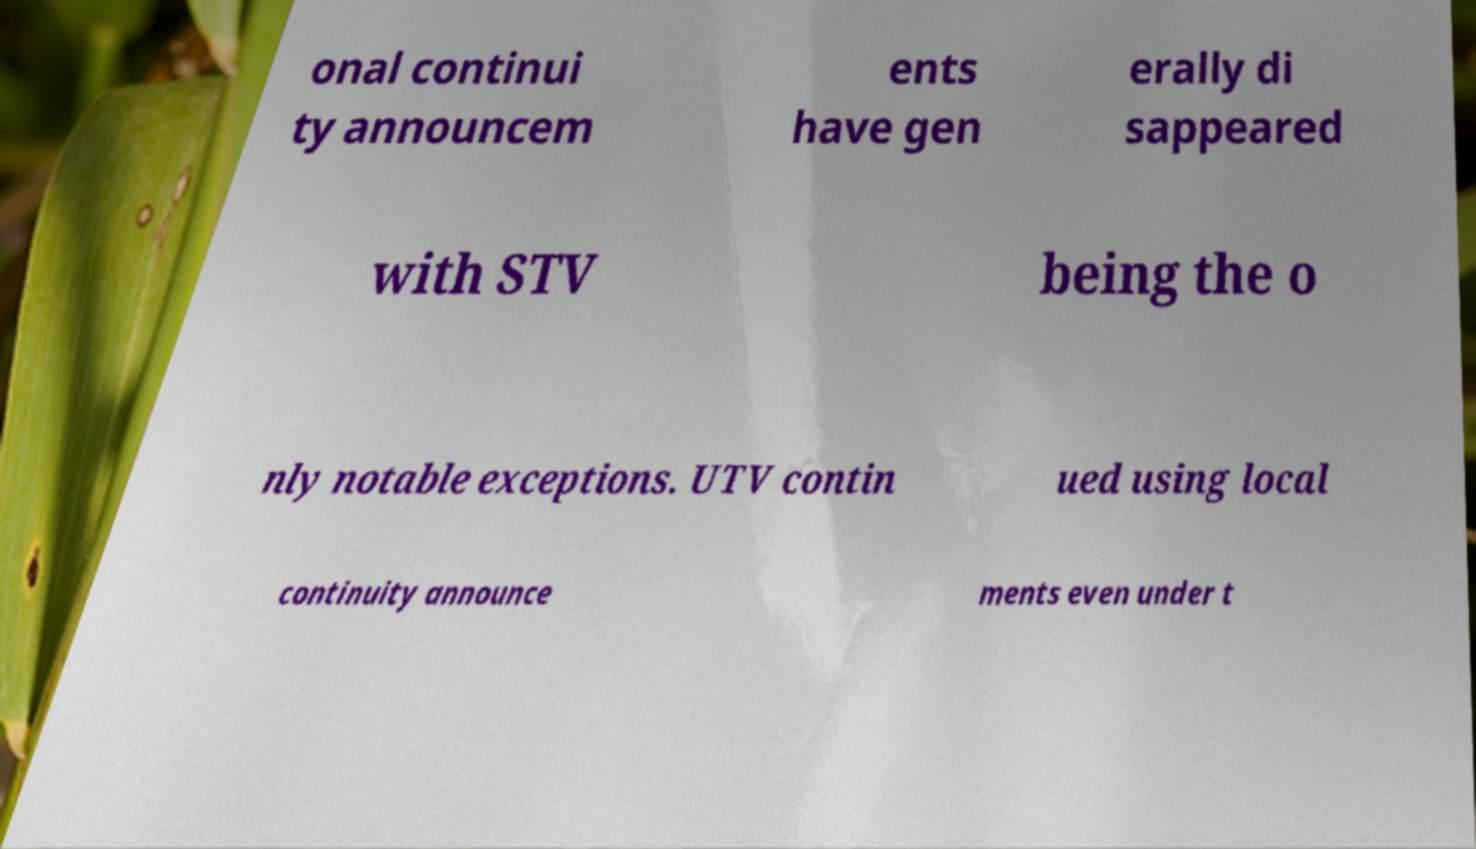Can you accurately transcribe the text from the provided image for me? onal continui ty announcem ents have gen erally di sappeared with STV being the o nly notable exceptions. UTV contin ued using local continuity announce ments even under t 